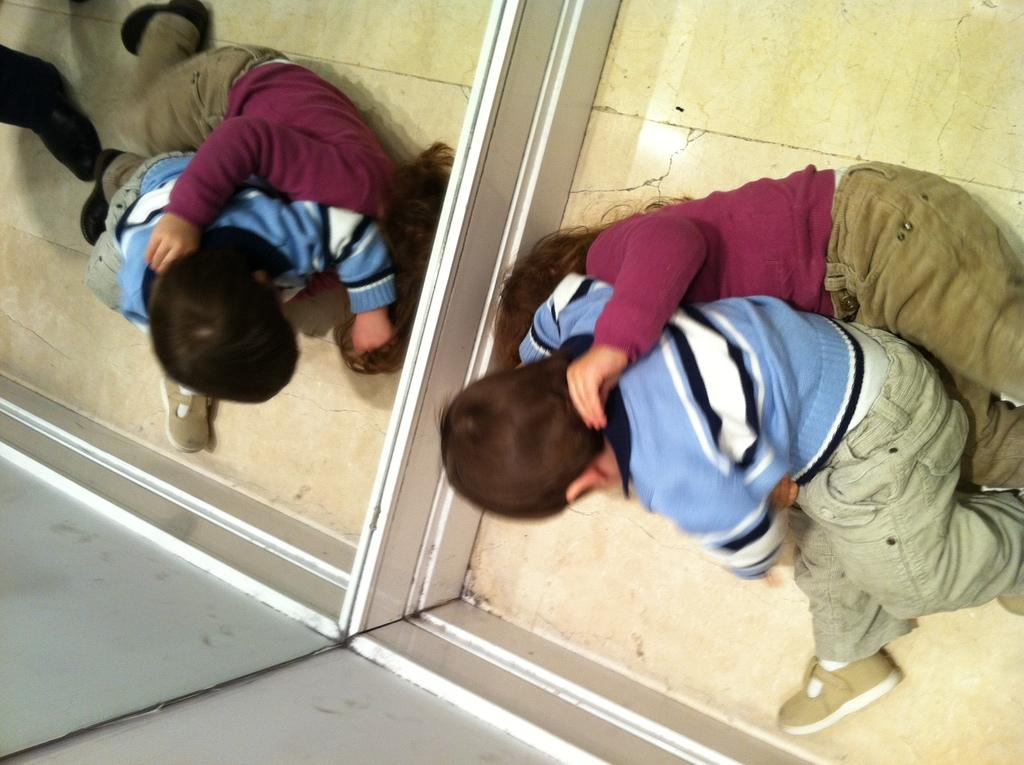How many children are present in the image? There are two children in the image. Where are the children located in the image? The children are on the floor. What can be seen in the background of the image? There is a wall and a mirror in the background of the image. What type of office furniture can be seen in the image? There is no office furniture present in the image. How many attempts did the children make to climb the wall in the image? The image does not show the children attempting to climb the wall, so it cannot be determined how many attempts they made. 